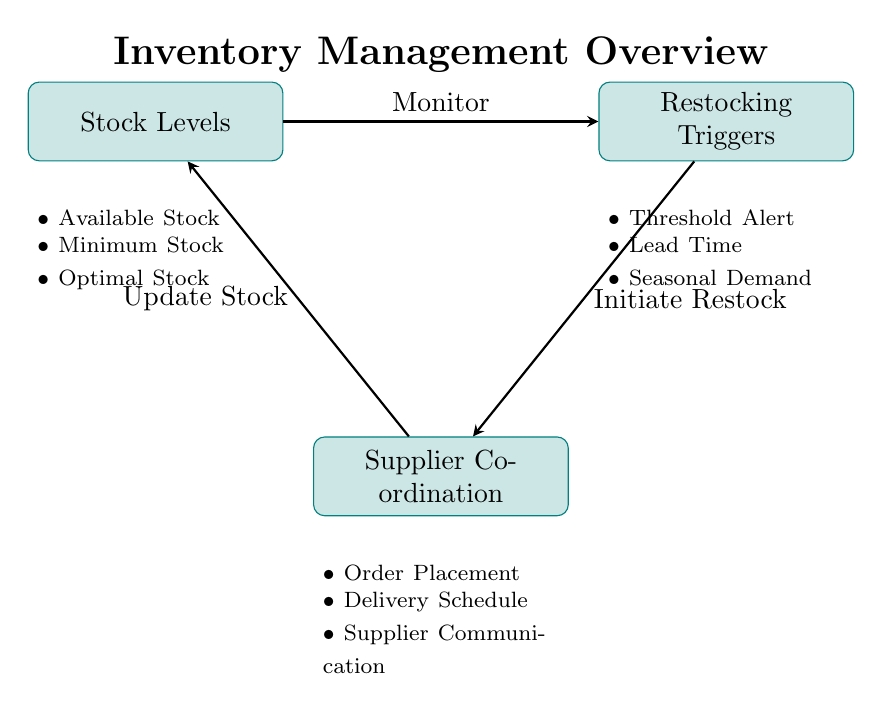What are the three main categories in the stock levels? The diagram lists three subcategories under Stock Levels. They are Available Stock, Minimum Stock, and Optimal Stock.
Answer: Available Stock, Minimum Stock, Optimal Stock How many main processes are depicted in the diagram? The diagram features three main process nodes: Stock Levels, Restocking Triggers, and Supplier Coordination. Thus, there are three main processes overall.
Answer: 3 What triggers the initiation of restock? The Restocking Triggers node in the diagram mentions that it is initiated by Threshold Alert, Lead Time, and Seasonal Demand. Therefore, these are the factors that trigger the initiation.
Answer: Threshold Alert, Lead Time, Seasonal Demand Which process receives updates from Supplier Coordination? The flow of the diagram shows that updates from Supplier Coordination go back to Stock Levels. This indicates that Supplier Coordination updates Stock Levels.
Answer: Stock Levels What is the relationship between Stock Levels and Restocking Triggers? The arrow labeled 'Monitor' connects Stock Levels to Restocking Triggers in the diagram. This indicates that Stock Levels are monitored to inform Restocking Triggers.
Answer: Monitor How does Supplier Coordination affect Stock Levels? According to the diagram, the Supplier Coordination process updates the Stock Levels, thereby affecting their status. This indicates a direct relationship where Supplier Coordination influences Stock Levels.
Answer: Update Stock What is the main purpose of Restocking Triggers as described in the diagram? The Restocking Triggers process has subcategories that include Threshold Alert, Lead Time, and Seasonal Demand, indicating its purpose is to monitor and respond to stock levels effectively.
Answer: Monitor stock levels Which process is directly below Restocking Triggers in the diagram? The diagram shows that Supplier Coordination is the process directly below Restocking Triggers, indicating a vertical relationship in the flow.
Answer: Supplier Coordination How does the flow of the diagram start? The flow begins with Stock Levels monitoring to trigger Restocking Triggers. Thus, Stock Levels act as the starting point for the flow of actions in the inventory management process.
Answer: Stock Levels 